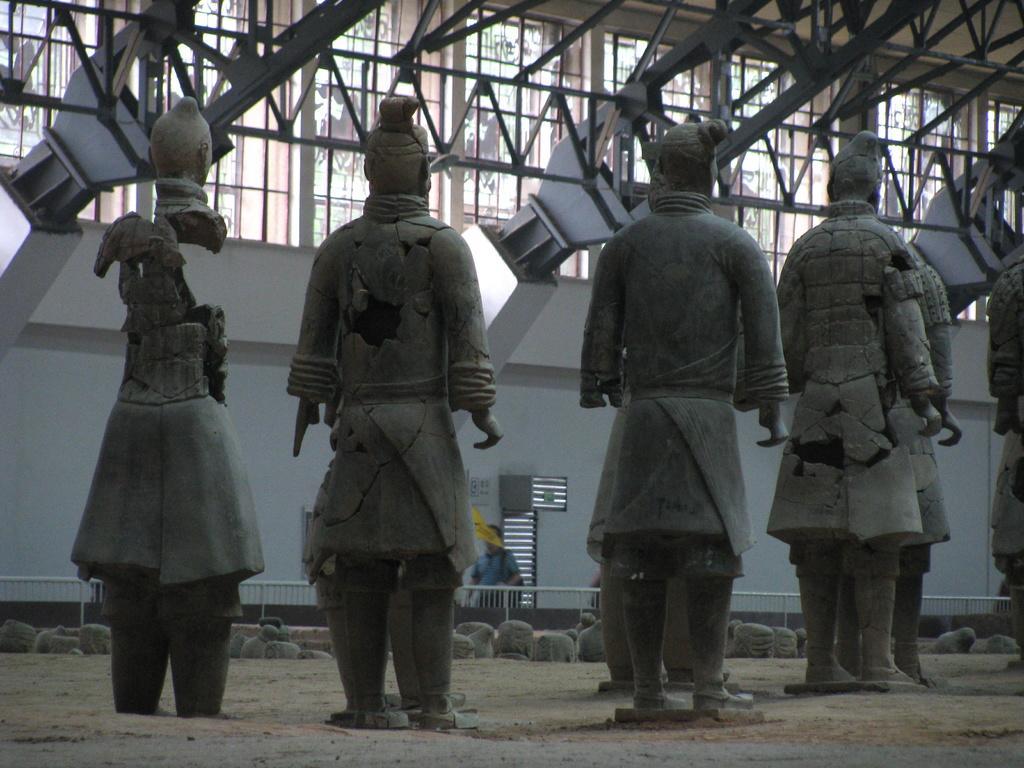In one or two sentences, can you explain what this image depicts? In the foreground of the picture I can see the statues. I can see the metal grill fence and these are looking like rocks. I can see a man and he is carrying a bag. I can see the metal scaffolding structure at the top of the picture. In the background, I can see the glass windows. 